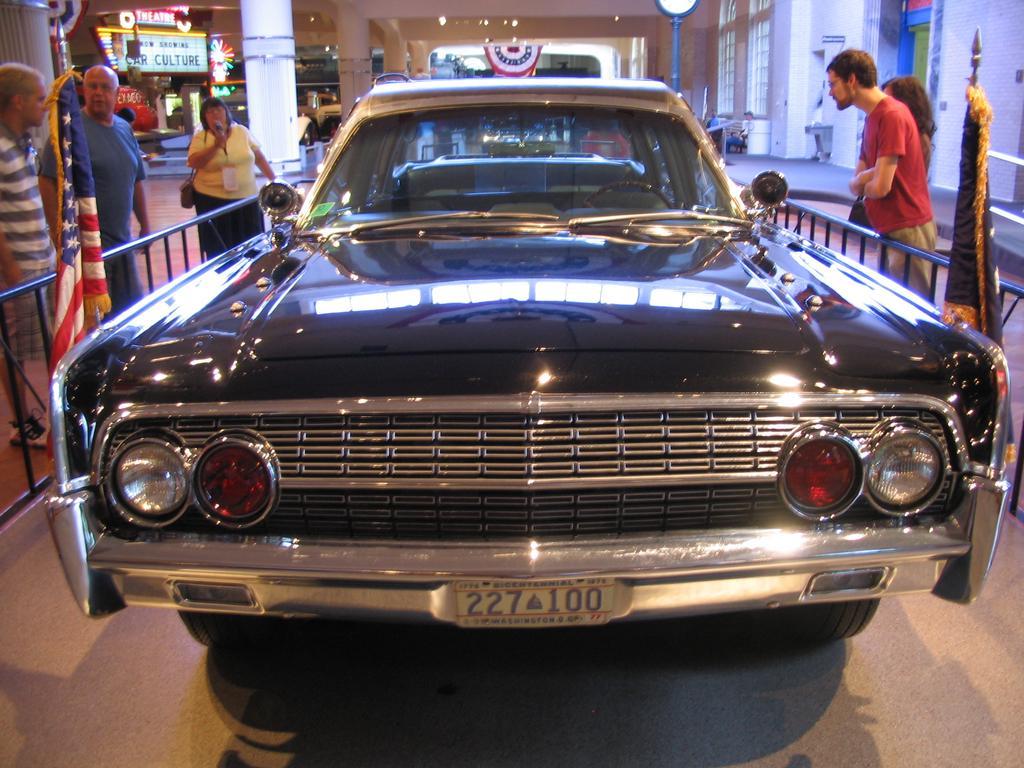Please provide a concise description of this image. In the center of the image there is a car with flags. To the both sides of the image there are people standing and there are railings. In the background of the image there is a building with ceiling. 